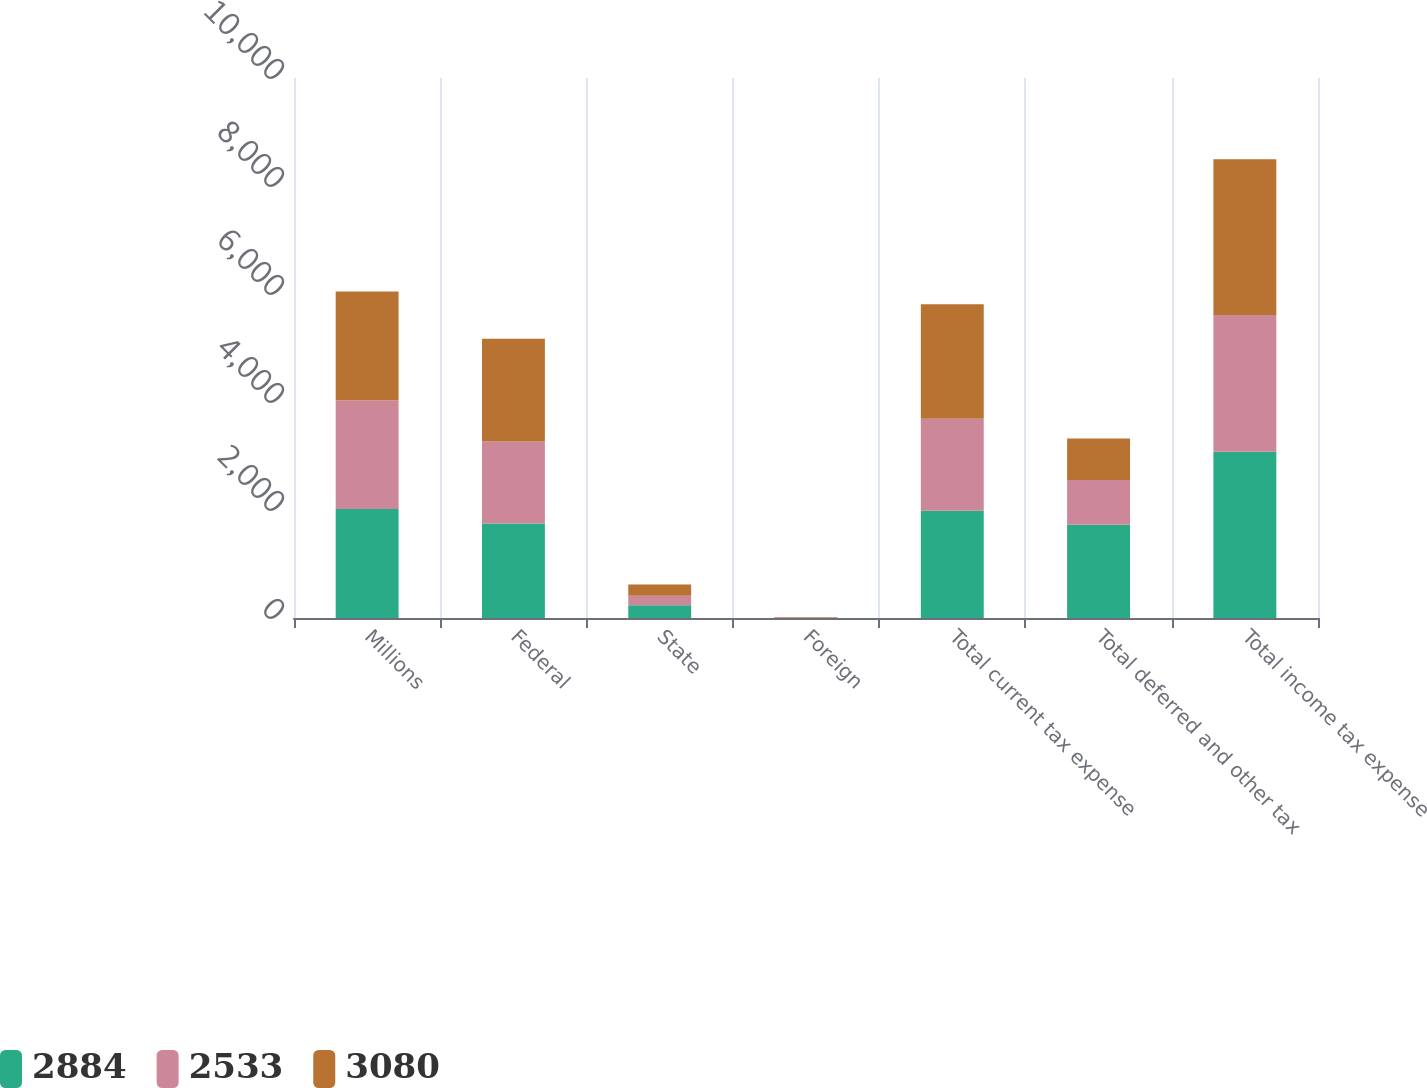Convert chart. <chart><loc_0><loc_0><loc_500><loc_500><stacked_bar_chart><ecel><fcel>Millions<fcel>Federal<fcel>State<fcel>Foreign<fcel>Total current tax expense<fcel>Total deferred and other tax<fcel>Total income tax expense<nl><fcel>2884<fcel>2017<fcel>1750<fcel>235<fcel>2<fcel>1987<fcel>1726<fcel>3080<nl><fcel>2533<fcel>2016<fcel>1518<fcel>176<fcel>8<fcel>1702<fcel>831<fcel>2533<nl><fcel>3080<fcel>2015<fcel>1901<fcel>210<fcel>8<fcel>2119<fcel>765<fcel>2884<nl></chart> 